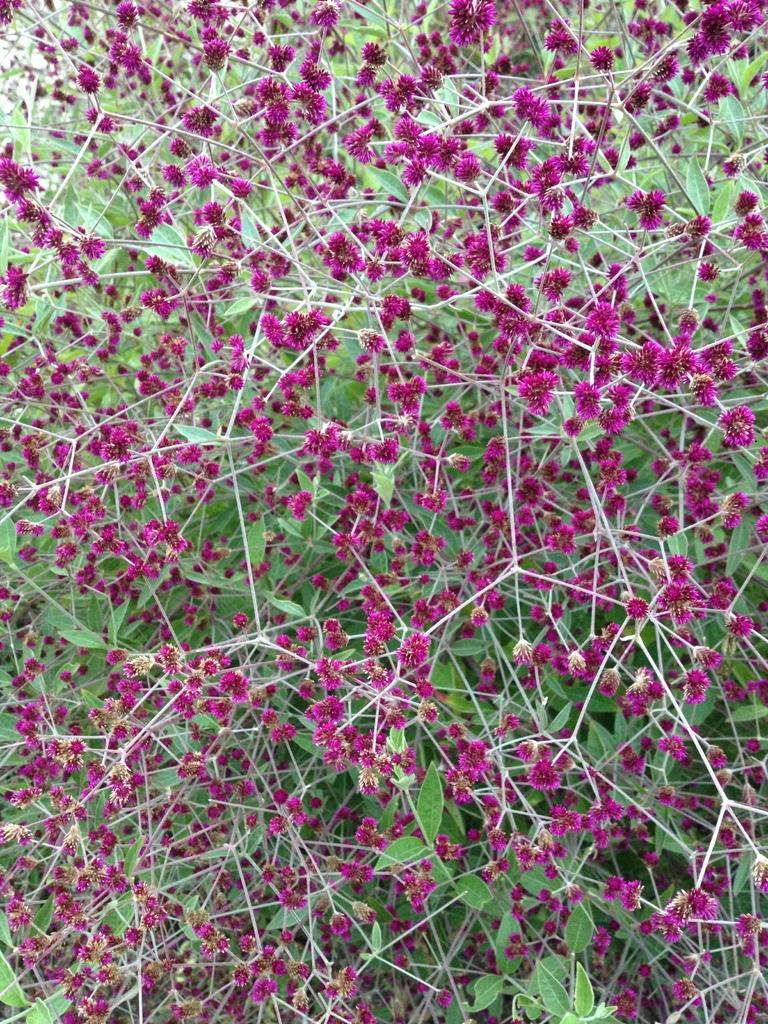What type of living organisms can be seen in the image? Plants can be seen in the image. What specific features do the plants have? The plants have flowers, and the flowers are pink in color. What color are the leaves of the plants? The leaves of the plants are green. What type of brass instrument is being played by the children in the image? There are no children or brass instruments present in the image; it features plants with pink flowers and green leaves. 